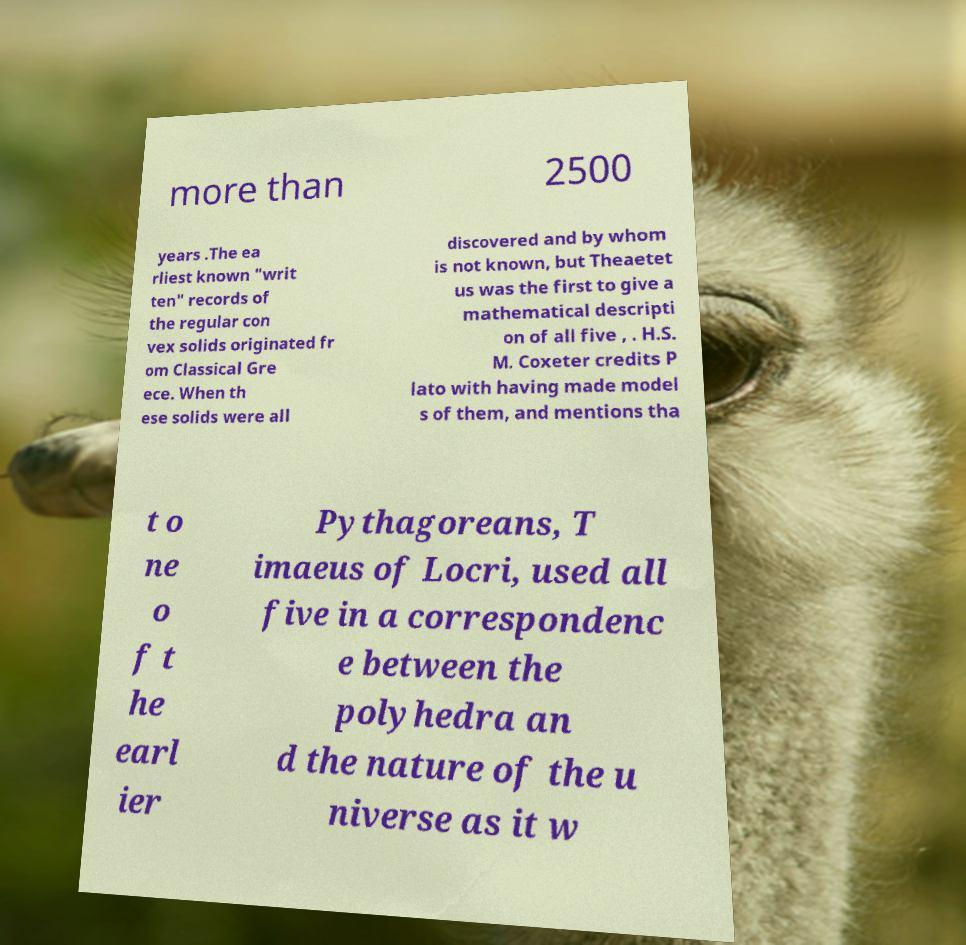Could you extract and type out the text from this image? more than 2500 years .The ea rliest known "writ ten" records of the regular con vex solids originated fr om Classical Gre ece. When th ese solids were all discovered and by whom is not known, but Theaetet us was the first to give a mathematical descripti on of all five , . H.S. M. Coxeter credits P lato with having made model s of them, and mentions tha t o ne o f t he earl ier Pythagoreans, T imaeus of Locri, used all five in a correspondenc e between the polyhedra an d the nature of the u niverse as it w 